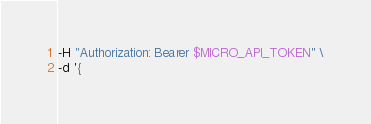Convert code to text. <code><loc_0><loc_0><loc_500><loc_500><_Bash_>-H "Authorization: Bearer $MICRO_API_TOKEN" \
-d '{</code> 